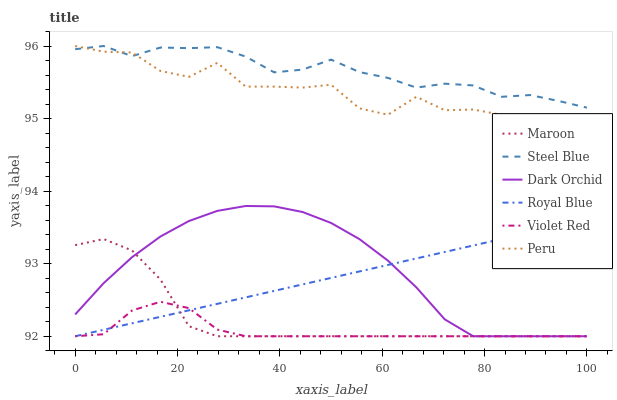Does Dark Orchid have the minimum area under the curve?
Answer yes or no. No. Does Dark Orchid have the maximum area under the curve?
Answer yes or no. No. Is Steel Blue the smoothest?
Answer yes or no. No. Is Steel Blue the roughest?
Answer yes or no. No. Does Steel Blue have the lowest value?
Answer yes or no. No. Does Dark Orchid have the highest value?
Answer yes or no. No. Is Royal Blue less than Peru?
Answer yes or no. Yes. Is Peru greater than Violet Red?
Answer yes or no. Yes. Does Royal Blue intersect Peru?
Answer yes or no. No. 